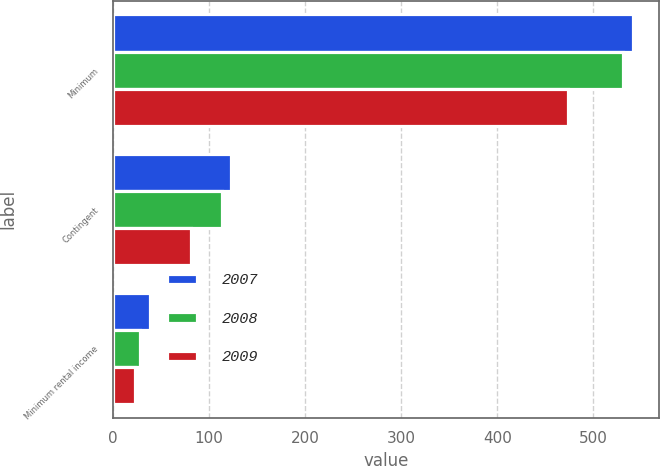<chart> <loc_0><loc_0><loc_500><loc_500><stacked_bar_chart><ecel><fcel>Minimum<fcel>Contingent<fcel>Minimum rental income<nl><fcel>2007<fcel>541<fcel>123<fcel>38<nl><fcel>2008<fcel>531<fcel>113<fcel>28<nl><fcel>2009<fcel>474<fcel>81<fcel>23<nl></chart> 